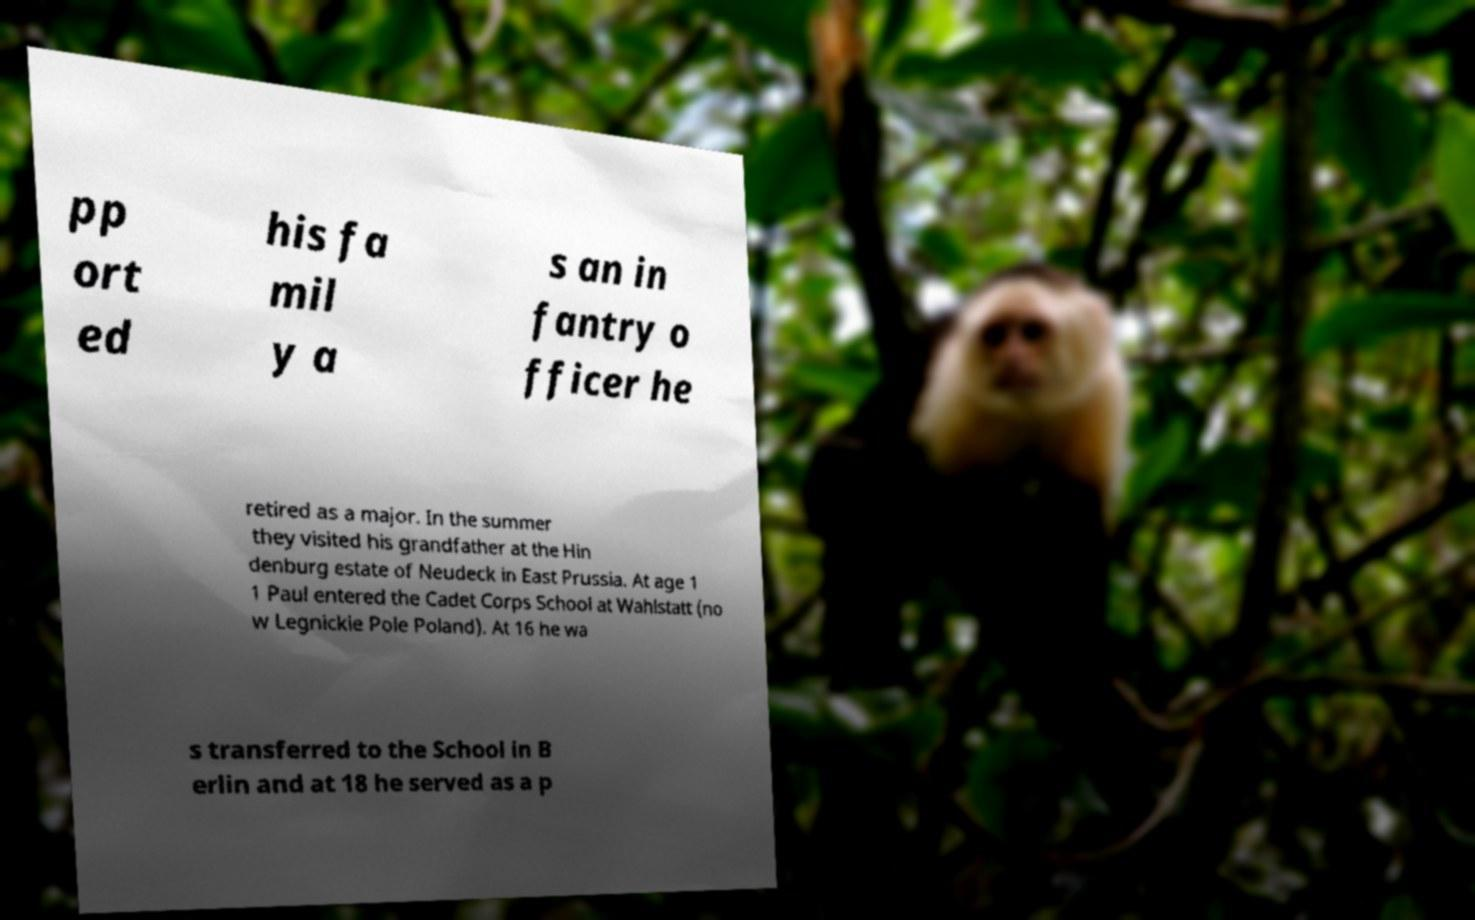Could you extract and type out the text from this image? pp ort ed his fa mil y a s an in fantry o fficer he retired as a major. In the summer they visited his grandfather at the Hin denburg estate of Neudeck in East Prussia. At age 1 1 Paul entered the Cadet Corps School at Wahlstatt (no w Legnickie Pole Poland). At 16 he wa s transferred to the School in B erlin and at 18 he served as a p 